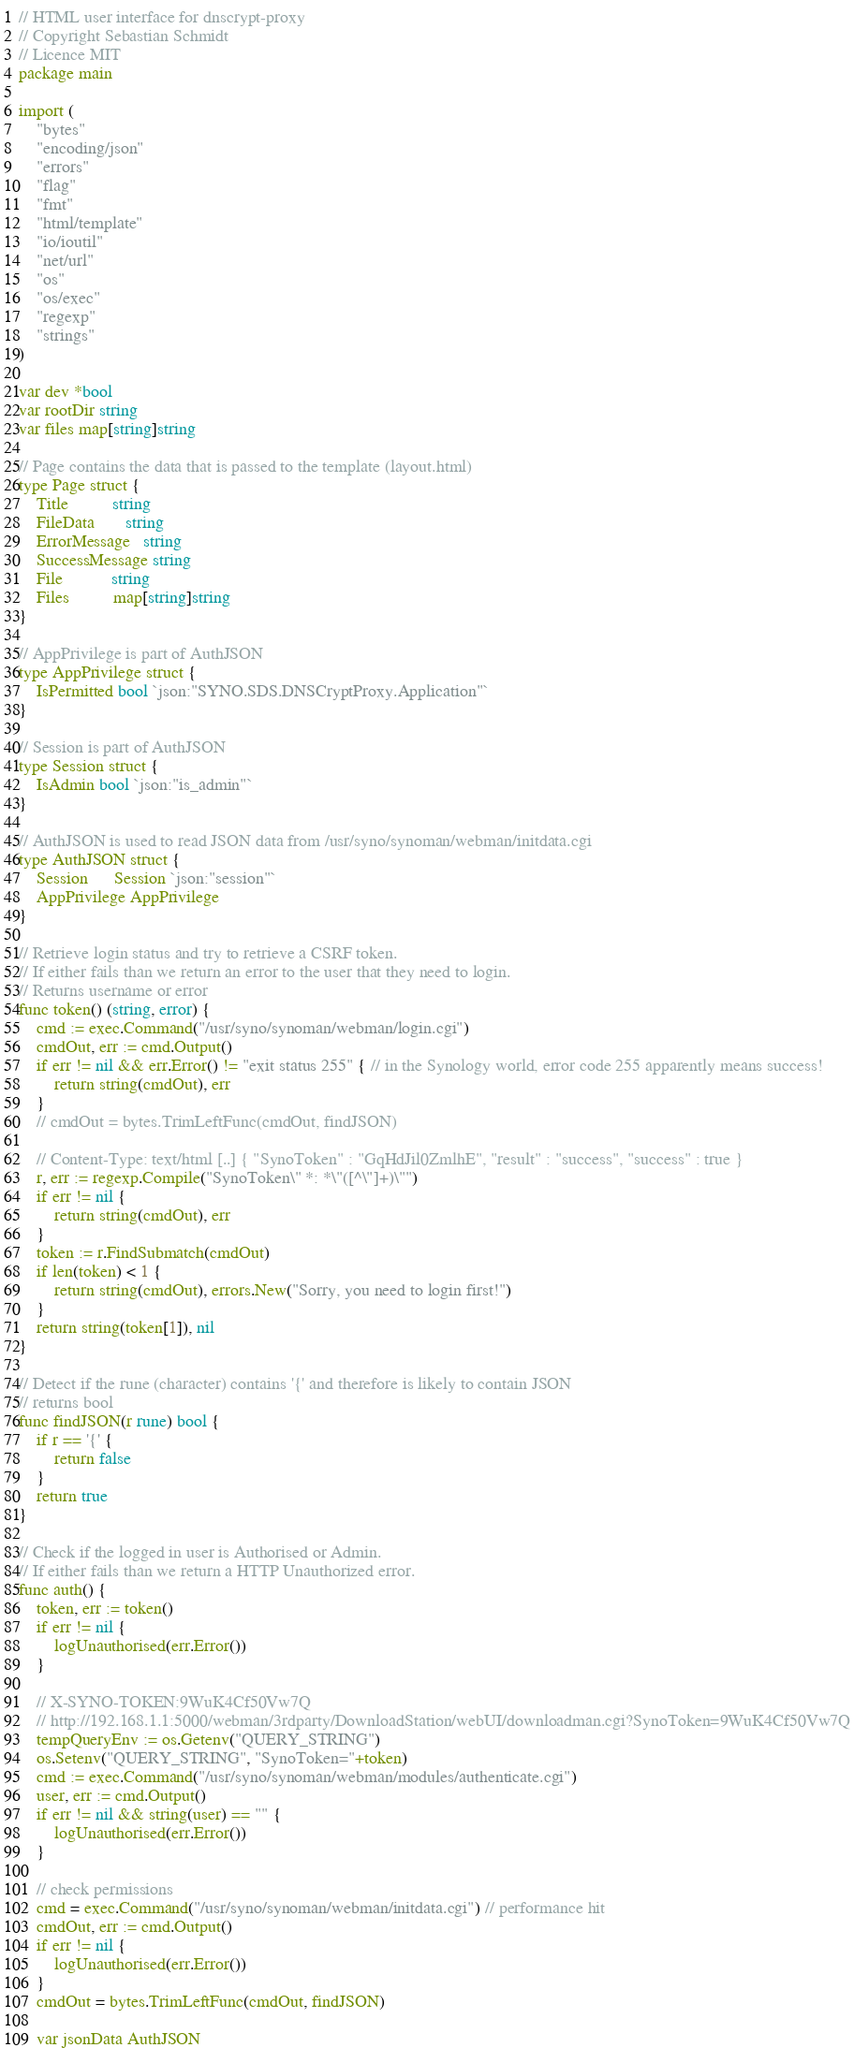Convert code to text. <code><loc_0><loc_0><loc_500><loc_500><_Go_>// HTML user interface for dnscrypt-proxy
// Copyright Sebastian Schmidt
// Licence MIT
package main

import (
    "bytes"
    "encoding/json"
    "errors"
    "flag"
    "fmt"
    "html/template"
    "io/ioutil"
    "net/url"
    "os"
    "os/exec"
    "regexp"
    "strings"
)

var dev *bool
var rootDir string
var files map[string]string

// Page contains the data that is passed to the template (layout.html)
type Page struct {
    Title          string
    FileData       string
    ErrorMessage   string
    SuccessMessage string
    File           string
    Files          map[string]string
}

// AppPrivilege is part of AuthJSON
type AppPrivilege struct {
    IsPermitted bool `json:"SYNO.SDS.DNSCryptProxy.Application"`
}

// Session is part of AuthJSON
type Session struct {
    IsAdmin bool `json:"is_admin"`
}

// AuthJSON is used to read JSON data from /usr/syno/synoman/webman/initdata.cgi
type AuthJSON struct {
    Session      Session `json:"session"`
    AppPrivilege AppPrivilege
}

// Retrieve login status and try to retrieve a CSRF token.
// If either fails than we return an error to the user that they need to login.
// Returns username or error
func token() (string, error) {
    cmd := exec.Command("/usr/syno/synoman/webman/login.cgi")
    cmdOut, err := cmd.Output()
    if err != nil && err.Error() != "exit status 255" { // in the Synology world, error code 255 apparently means success!
        return string(cmdOut), err
    }
    // cmdOut = bytes.TrimLeftFunc(cmdOut, findJSON)

    // Content-Type: text/html [..] { "SynoToken" : "GqHdJil0ZmlhE", "result" : "success", "success" : true }
    r, err := regexp.Compile("SynoToken\" *: *\"([^\"]+)\"")
    if err != nil {
        return string(cmdOut), err
    }
    token := r.FindSubmatch(cmdOut)
    if len(token) < 1 {
        return string(cmdOut), errors.New("Sorry, you need to login first!")
    }
    return string(token[1]), nil
}

// Detect if the rune (character) contains '{' and therefore is likely to contain JSON
// returns bool
func findJSON(r rune) bool {
    if r == '{' {
        return false
    }
    return true
}

// Check if the logged in user is Authorised or Admin.
// If either fails than we return a HTTP Unauthorized error.
func auth() {
    token, err := token()
    if err != nil {
        logUnauthorised(err.Error())
    }

    // X-SYNO-TOKEN:9WuK4Cf50Vw7Q
    // http://192.168.1.1:5000/webman/3rdparty/DownloadStation/webUI/downloadman.cgi?SynoToken=9WuK4Cf50Vw7Q
    tempQueryEnv := os.Getenv("QUERY_STRING")
    os.Setenv("QUERY_STRING", "SynoToken="+token)
    cmd := exec.Command("/usr/syno/synoman/webman/modules/authenticate.cgi")
    user, err := cmd.Output()
    if err != nil && string(user) == "" {
        logUnauthorised(err.Error())
    }

    // check permissions
    cmd = exec.Command("/usr/syno/synoman/webman/initdata.cgi") // performance hit
    cmdOut, err := cmd.Output()
    if err != nil {
        logUnauthorised(err.Error())
    }
    cmdOut = bytes.TrimLeftFunc(cmdOut, findJSON)

    var jsonData AuthJSON</code> 